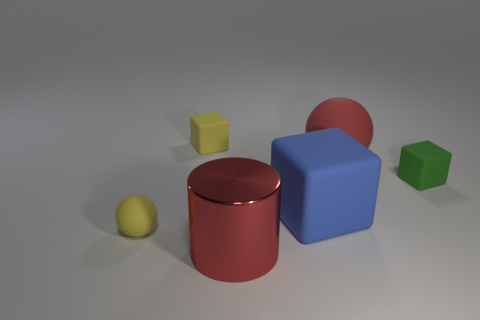Subtract all tiny blocks. How many blocks are left? 1 Add 3 tiny things. How many objects exist? 9 Subtract all yellow blocks. How many blocks are left? 2 Subtract all cylinders. How many objects are left? 5 Add 6 large red metal cylinders. How many large red metal cylinders are left? 7 Add 5 red objects. How many red objects exist? 7 Subtract 0 cyan balls. How many objects are left? 6 Subtract all purple balls. Subtract all blue cylinders. How many balls are left? 2 Subtract all large blue blocks. Subtract all blue rubber things. How many objects are left? 4 